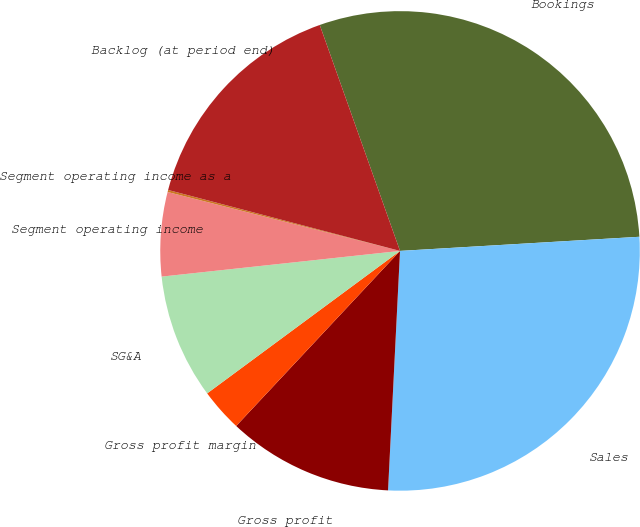<chart> <loc_0><loc_0><loc_500><loc_500><pie_chart><fcel>Bookings<fcel>Sales<fcel>Gross profit<fcel>Gross profit margin<fcel>SG&A<fcel>Segment operating income<fcel>Segment operating income as a<fcel>Backlog (at period end)<nl><fcel>29.5%<fcel>26.74%<fcel>11.18%<fcel>2.9%<fcel>8.42%<fcel>5.66%<fcel>0.14%<fcel>15.48%<nl></chart> 